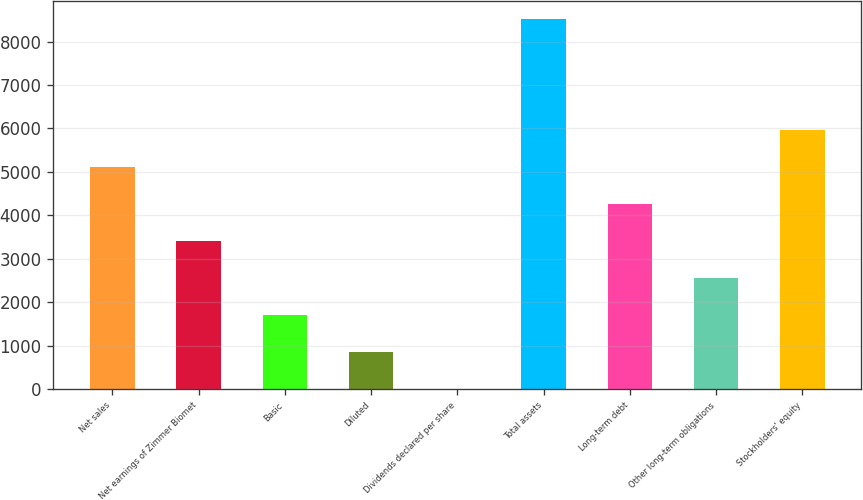Convert chart to OTSL. <chart><loc_0><loc_0><loc_500><loc_500><bar_chart><fcel>Net sales<fcel>Net earnings of Zimmer Biomet<fcel>Basic<fcel>Diluted<fcel>Dividends declared per share<fcel>Total assets<fcel>Long-term debt<fcel>Other long-term obligations<fcel>Stockholders' equity<nl><fcel>5108.7<fcel>3405.86<fcel>1703.02<fcel>851.6<fcel>0.18<fcel>8514.4<fcel>4257.28<fcel>2554.44<fcel>5960.12<nl></chart> 